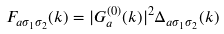<formula> <loc_0><loc_0><loc_500><loc_500>F _ { a \sigma _ { 1 } \sigma _ { 2 } } ( k ) = | G _ { a } ^ { ( 0 ) } ( k ) | ^ { 2 } \Delta _ { a \sigma _ { 1 } \sigma _ { 2 } } ( k )</formula> 